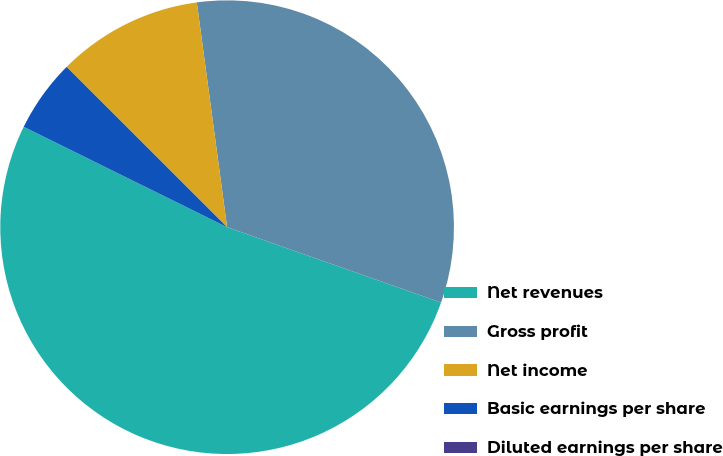Convert chart. <chart><loc_0><loc_0><loc_500><loc_500><pie_chart><fcel>Net revenues<fcel>Gross profit<fcel>Net income<fcel>Basic earnings per share<fcel>Diluted earnings per share<nl><fcel>51.91%<fcel>32.52%<fcel>10.38%<fcel>5.19%<fcel>0.0%<nl></chart> 